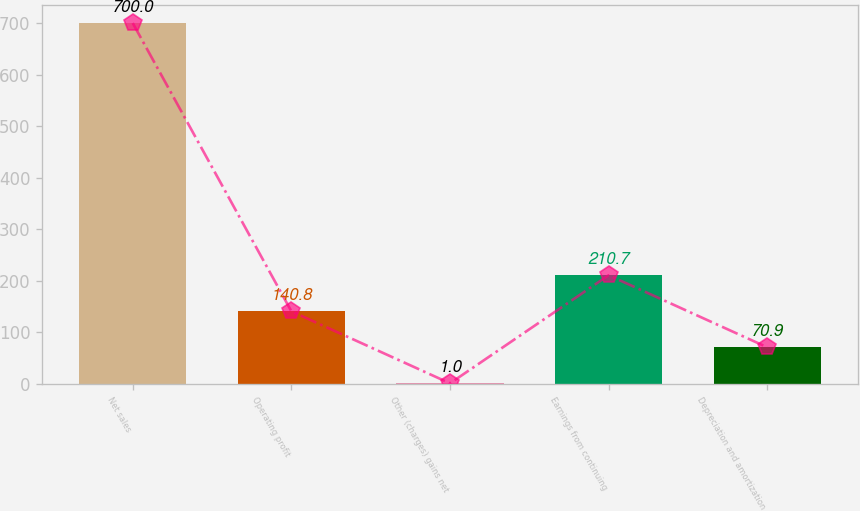Convert chart. <chart><loc_0><loc_0><loc_500><loc_500><bar_chart><fcel>Net sales<fcel>Operating profit<fcel>Other (charges) gains net<fcel>Earnings from continuing<fcel>Depreciation and amortization<nl><fcel>700<fcel>140.8<fcel>1<fcel>210.7<fcel>70.9<nl></chart> 